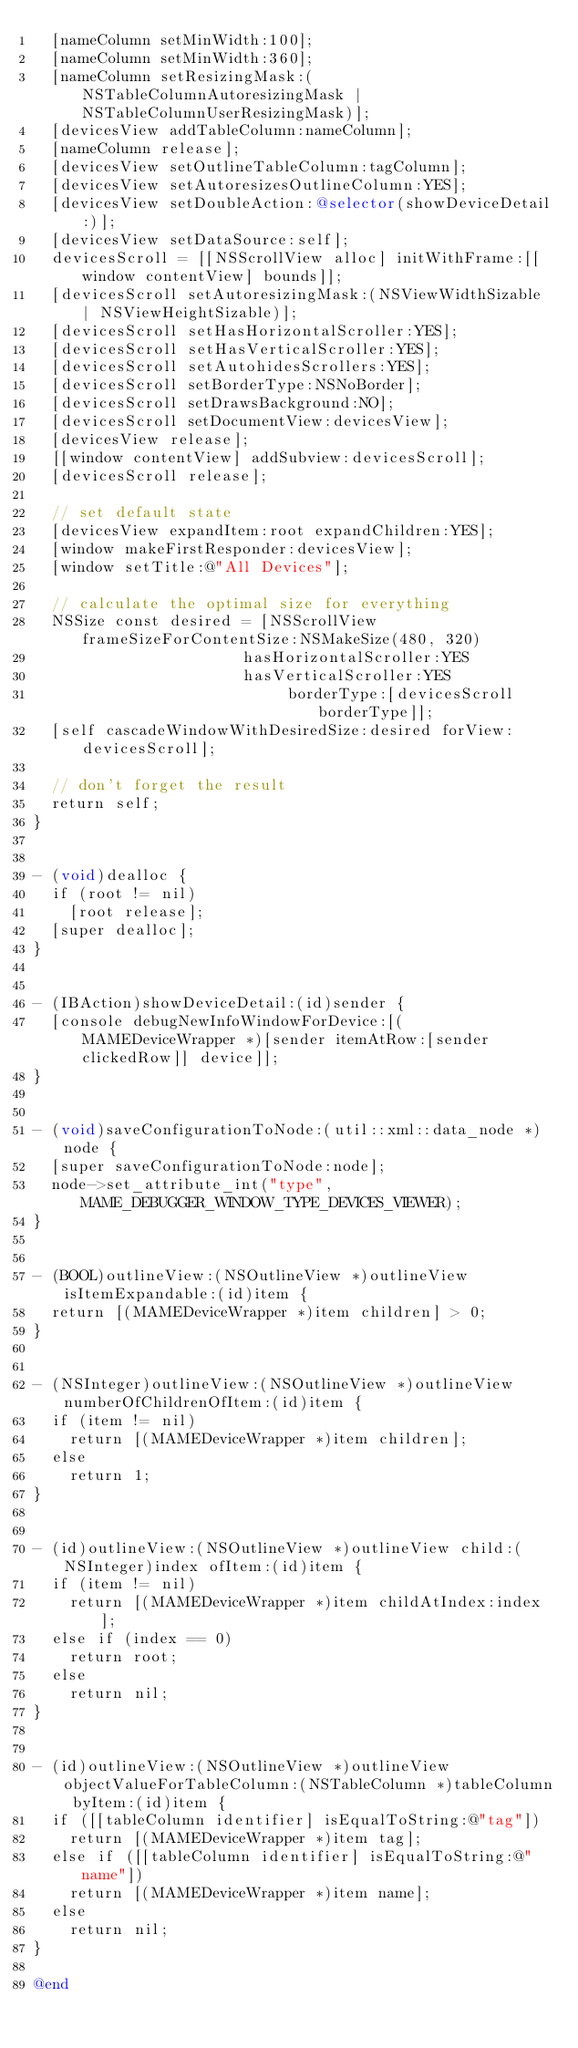<code> <loc_0><loc_0><loc_500><loc_500><_ObjectiveC_>	[nameColumn setMinWidth:100];
	[nameColumn setMinWidth:360];
	[nameColumn setResizingMask:(NSTableColumnAutoresizingMask | NSTableColumnUserResizingMask)];
	[devicesView addTableColumn:nameColumn];
	[nameColumn release];
	[devicesView setOutlineTableColumn:tagColumn];
	[devicesView setAutoresizesOutlineColumn:YES];
	[devicesView setDoubleAction:@selector(showDeviceDetail:)];
	[devicesView setDataSource:self];
	devicesScroll = [[NSScrollView alloc] initWithFrame:[[window contentView] bounds]];
	[devicesScroll setAutoresizingMask:(NSViewWidthSizable | NSViewHeightSizable)];
	[devicesScroll setHasHorizontalScroller:YES];
	[devicesScroll setHasVerticalScroller:YES];
	[devicesScroll setAutohidesScrollers:YES];
	[devicesScroll setBorderType:NSNoBorder];
	[devicesScroll setDrawsBackground:NO];
	[devicesScroll setDocumentView:devicesView];
	[devicesView release];
	[[window contentView] addSubview:devicesScroll];
	[devicesScroll release];

	// set default state
	[devicesView expandItem:root expandChildren:YES];
	[window makeFirstResponder:devicesView];
	[window setTitle:@"All Devices"];

	// calculate the optimal size for everything
	NSSize const desired = [NSScrollView frameSizeForContentSize:NSMakeSize(480, 320)
										   hasHorizontalScroller:YES
											 hasVerticalScroller:YES
													  borderType:[devicesScroll borderType]];
	[self cascadeWindowWithDesiredSize:desired forView:devicesScroll];

	// don't forget the result
	return self;
}


- (void)dealloc {
	if (root != nil)
		[root release];
	[super dealloc];
}


- (IBAction)showDeviceDetail:(id)sender {
	[console debugNewInfoWindowForDevice:[(MAMEDeviceWrapper *)[sender itemAtRow:[sender clickedRow]] device]];
}


- (void)saveConfigurationToNode:(util::xml::data_node *)node {
	[super saveConfigurationToNode:node];
	node->set_attribute_int("type", MAME_DEBUGGER_WINDOW_TYPE_DEVICES_VIEWER);
}


- (BOOL)outlineView:(NSOutlineView *)outlineView isItemExpandable:(id)item {
	return [(MAMEDeviceWrapper *)item children] > 0;
}


- (NSInteger)outlineView:(NSOutlineView *)outlineView numberOfChildrenOfItem:(id)item {
	if (item != nil)
		return [(MAMEDeviceWrapper *)item children];
	else
		return 1;
}


- (id)outlineView:(NSOutlineView *)outlineView child:(NSInteger)index ofItem:(id)item {
	if (item != nil)
		return [(MAMEDeviceWrapper *)item childAtIndex:index];
	else if (index == 0)
		return root;
	else
		return nil;
}


- (id)outlineView:(NSOutlineView *)outlineView objectValueForTableColumn:(NSTableColumn *)tableColumn byItem:(id)item {
	if ([[tableColumn identifier] isEqualToString:@"tag"])
		return [(MAMEDeviceWrapper *)item tag];
	else if ([[tableColumn identifier] isEqualToString:@"name"])
		return [(MAMEDeviceWrapper *)item name];
	else
		return nil;
}

@end
</code> 